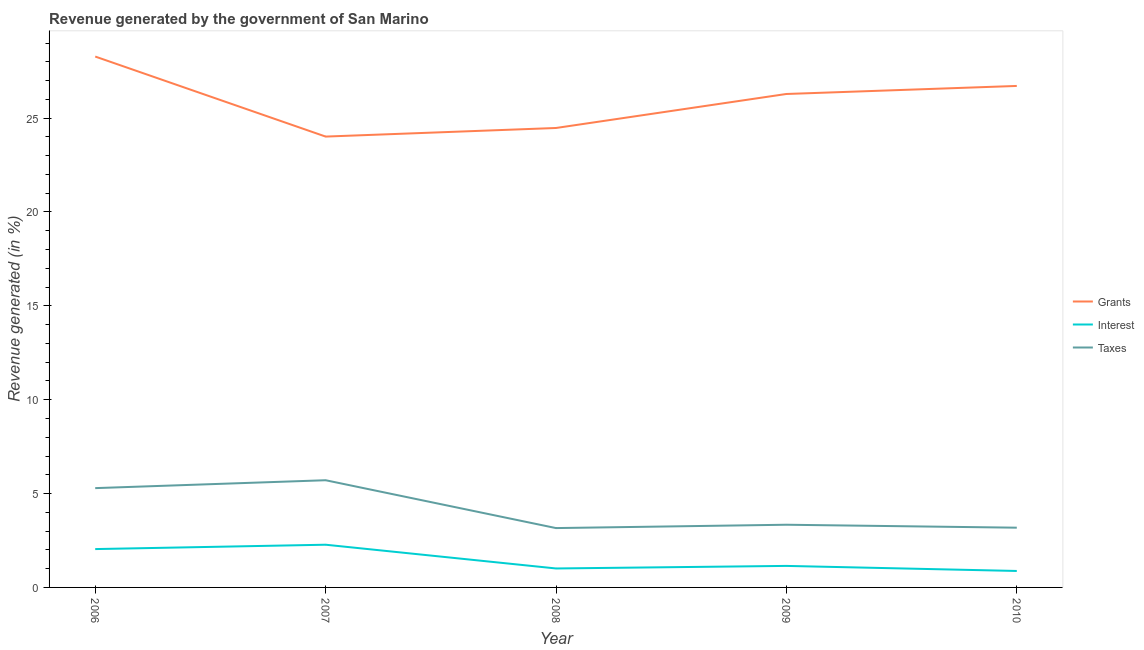How many different coloured lines are there?
Your answer should be compact. 3. Does the line corresponding to percentage of revenue generated by interest intersect with the line corresponding to percentage of revenue generated by taxes?
Make the answer very short. No. What is the percentage of revenue generated by taxes in 2010?
Offer a very short reply. 3.18. Across all years, what is the maximum percentage of revenue generated by interest?
Your answer should be compact. 2.28. Across all years, what is the minimum percentage of revenue generated by grants?
Keep it short and to the point. 24.02. In which year was the percentage of revenue generated by interest maximum?
Give a very brief answer. 2007. In which year was the percentage of revenue generated by interest minimum?
Ensure brevity in your answer.  2010. What is the total percentage of revenue generated by grants in the graph?
Make the answer very short. 129.77. What is the difference between the percentage of revenue generated by taxes in 2006 and that in 2007?
Give a very brief answer. -0.42. What is the difference between the percentage of revenue generated by taxes in 2007 and the percentage of revenue generated by interest in 2010?
Give a very brief answer. 4.83. What is the average percentage of revenue generated by taxes per year?
Ensure brevity in your answer.  4.14. In the year 2006, what is the difference between the percentage of revenue generated by grants and percentage of revenue generated by interest?
Your response must be concise. 26.24. In how many years, is the percentage of revenue generated by interest greater than 10 %?
Provide a short and direct response. 0. What is the ratio of the percentage of revenue generated by interest in 2007 to that in 2009?
Offer a terse response. 1.98. Is the difference between the percentage of revenue generated by taxes in 2006 and 2008 greater than the difference between the percentage of revenue generated by grants in 2006 and 2008?
Provide a short and direct response. No. What is the difference between the highest and the second highest percentage of revenue generated by grants?
Provide a succinct answer. 1.57. What is the difference between the highest and the lowest percentage of revenue generated by grants?
Make the answer very short. 4.26. In how many years, is the percentage of revenue generated by taxes greater than the average percentage of revenue generated by taxes taken over all years?
Your response must be concise. 2. Is the sum of the percentage of revenue generated by grants in 2007 and 2008 greater than the maximum percentage of revenue generated by interest across all years?
Your response must be concise. Yes. Does the percentage of revenue generated by interest monotonically increase over the years?
Make the answer very short. No. Is the percentage of revenue generated by taxes strictly greater than the percentage of revenue generated by grants over the years?
Provide a succinct answer. No. Is the percentage of revenue generated by grants strictly less than the percentage of revenue generated by taxes over the years?
Provide a short and direct response. No. How many lines are there?
Provide a short and direct response. 3. How many years are there in the graph?
Provide a short and direct response. 5. What is the difference between two consecutive major ticks on the Y-axis?
Ensure brevity in your answer.  5. Does the graph contain any zero values?
Offer a very short reply. No. Does the graph contain grids?
Provide a succinct answer. No. Where does the legend appear in the graph?
Your response must be concise. Center right. How many legend labels are there?
Make the answer very short. 3. What is the title of the graph?
Provide a short and direct response. Revenue generated by the government of San Marino. Does "Central government" appear as one of the legend labels in the graph?
Offer a terse response. No. What is the label or title of the X-axis?
Offer a terse response. Year. What is the label or title of the Y-axis?
Ensure brevity in your answer.  Revenue generated (in %). What is the Revenue generated (in %) in Grants in 2006?
Keep it short and to the point. 28.28. What is the Revenue generated (in %) in Interest in 2006?
Offer a terse response. 2.04. What is the Revenue generated (in %) of Taxes in 2006?
Provide a succinct answer. 5.29. What is the Revenue generated (in %) of Grants in 2007?
Your answer should be compact. 24.02. What is the Revenue generated (in %) in Interest in 2007?
Your answer should be compact. 2.28. What is the Revenue generated (in %) of Taxes in 2007?
Offer a very short reply. 5.71. What is the Revenue generated (in %) in Grants in 2008?
Keep it short and to the point. 24.47. What is the Revenue generated (in %) of Interest in 2008?
Your answer should be very brief. 1.01. What is the Revenue generated (in %) of Taxes in 2008?
Keep it short and to the point. 3.16. What is the Revenue generated (in %) in Grants in 2009?
Keep it short and to the point. 26.28. What is the Revenue generated (in %) in Interest in 2009?
Offer a very short reply. 1.15. What is the Revenue generated (in %) of Taxes in 2009?
Provide a short and direct response. 3.34. What is the Revenue generated (in %) in Grants in 2010?
Provide a short and direct response. 26.71. What is the Revenue generated (in %) in Interest in 2010?
Give a very brief answer. 0.88. What is the Revenue generated (in %) of Taxes in 2010?
Your response must be concise. 3.18. Across all years, what is the maximum Revenue generated (in %) in Grants?
Offer a very short reply. 28.28. Across all years, what is the maximum Revenue generated (in %) in Interest?
Provide a succinct answer. 2.28. Across all years, what is the maximum Revenue generated (in %) of Taxes?
Your response must be concise. 5.71. Across all years, what is the minimum Revenue generated (in %) of Grants?
Ensure brevity in your answer.  24.02. Across all years, what is the minimum Revenue generated (in %) in Interest?
Offer a very short reply. 0.88. Across all years, what is the minimum Revenue generated (in %) in Taxes?
Provide a short and direct response. 3.16. What is the total Revenue generated (in %) of Grants in the graph?
Your answer should be very brief. 129.77. What is the total Revenue generated (in %) in Interest in the graph?
Your answer should be compact. 7.35. What is the total Revenue generated (in %) of Taxes in the graph?
Offer a terse response. 20.68. What is the difference between the Revenue generated (in %) in Grants in 2006 and that in 2007?
Provide a succinct answer. 4.26. What is the difference between the Revenue generated (in %) in Interest in 2006 and that in 2007?
Provide a short and direct response. -0.23. What is the difference between the Revenue generated (in %) of Taxes in 2006 and that in 2007?
Your answer should be very brief. -0.42. What is the difference between the Revenue generated (in %) of Grants in 2006 and that in 2008?
Provide a succinct answer. 3.81. What is the difference between the Revenue generated (in %) in Interest in 2006 and that in 2008?
Give a very brief answer. 1.03. What is the difference between the Revenue generated (in %) of Taxes in 2006 and that in 2008?
Offer a very short reply. 2.13. What is the difference between the Revenue generated (in %) of Grants in 2006 and that in 2009?
Provide a succinct answer. 1.99. What is the difference between the Revenue generated (in %) of Interest in 2006 and that in 2009?
Your answer should be compact. 0.9. What is the difference between the Revenue generated (in %) in Taxes in 2006 and that in 2009?
Your response must be concise. 1.95. What is the difference between the Revenue generated (in %) in Grants in 2006 and that in 2010?
Your response must be concise. 1.57. What is the difference between the Revenue generated (in %) of Interest in 2006 and that in 2010?
Keep it short and to the point. 1.17. What is the difference between the Revenue generated (in %) in Taxes in 2006 and that in 2010?
Give a very brief answer. 2.11. What is the difference between the Revenue generated (in %) of Grants in 2007 and that in 2008?
Provide a short and direct response. -0.46. What is the difference between the Revenue generated (in %) in Interest in 2007 and that in 2008?
Provide a succinct answer. 1.27. What is the difference between the Revenue generated (in %) in Taxes in 2007 and that in 2008?
Offer a very short reply. 2.55. What is the difference between the Revenue generated (in %) of Grants in 2007 and that in 2009?
Your answer should be compact. -2.27. What is the difference between the Revenue generated (in %) of Interest in 2007 and that in 2009?
Ensure brevity in your answer.  1.13. What is the difference between the Revenue generated (in %) in Taxes in 2007 and that in 2009?
Offer a very short reply. 2.37. What is the difference between the Revenue generated (in %) of Grants in 2007 and that in 2010?
Keep it short and to the point. -2.7. What is the difference between the Revenue generated (in %) in Interest in 2007 and that in 2010?
Provide a succinct answer. 1.4. What is the difference between the Revenue generated (in %) in Taxes in 2007 and that in 2010?
Provide a short and direct response. 2.53. What is the difference between the Revenue generated (in %) of Grants in 2008 and that in 2009?
Give a very brief answer. -1.81. What is the difference between the Revenue generated (in %) in Interest in 2008 and that in 2009?
Offer a very short reply. -0.14. What is the difference between the Revenue generated (in %) of Taxes in 2008 and that in 2009?
Make the answer very short. -0.18. What is the difference between the Revenue generated (in %) of Grants in 2008 and that in 2010?
Make the answer very short. -2.24. What is the difference between the Revenue generated (in %) in Interest in 2008 and that in 2010?
Offer a terse response. 0.13. What is the difference between the Revenue generated (in %) of Taxes in 2008 and that in 2010?
Keep it short and to the point. -0.02. What is the difference between the Revenue generated (in %) of Grants in 2009 and that in 2010?
Your answer should be compact. -0.43. What is the difference between the Revenue generated (in %) of Interest in 2009 and that in 2010?
Your response must be concise. 0.27. What is the difference between the Revenue generated (in %) of Taxes in 2009 and that in 2010?
Ensure brevity in your answer.  0.16. What is the difference between the Revenue generated (in %) in Grants in 2006 and the Revenue generated (in %) in Interest in 2007?
Offer a very short reply. 26. What is the difference between the Revenue generated (in %) of Grants in 2006 and the Revenue generated (in %) of Taxes in 2007?
Your answer should be very brief. 22.57. What is the difference between the Revenue generated (in %) in Interest in 2006 and the Revenue generated (in %) in Taxes in 2007?
Provide a short and direct response. -3.67. What is the difference between the Revenue generated (in %) in Grants in 2006 and the Revenue generated (in %) in Interest in 2008?
Ensure brevity in your answer.  27.27. What is the difference between the Revenue generated (in %) of Grants in 2006 and the Revenue generated (in %) of Taxes in 2008?
Give a very brief answer. 25.12. What is the difference between the Revenue generated (in %) in Interest in 2006 and the Revenue generated (in %) in Taxes in 2008?
Provide a succinct answer. -1.12. What is the difference between the Revenue generated (in %) of Grants in 2006 and the Revenue generated (in %) of Interest in 2009?
Ensure brevity in your answer.  27.13. What is the difference between the Revenue generated (in %) of Grants in 2006 and the Revenue generated (in %) of Taxes in 2009?
Offer a terse response. 24.94. What is the difference between the Revenue generated (in %) in Interest in 2006 and the Revenue generated (in %) in Taxes in 2009?
Give a very brief answer. -1.3. What is the difference between the Revenue generated (in %) in Grants in 2006 and the Revenue generated (in %) in Interest in 2010?
Provide a short and direct response. 27.4. What is the difference between the Revenue generated (in %) in Grants in 2006 and the Revenue generated (in %) in Taxes in 2010?
Offer a terse response. 25.1. What is the difference between the Revenue generated (in %) in Interest in 2006 and the Revenue generated (in %) in Taxes in 2010?
Your response must be concise. -1.14. What is the difference between the Revenue generated (in %) in Grants in 2007 and the Revenue generated (in %) in Interest in 2008?
Make the answer very short. 23.01. What is the difference between the Revenue generated (in %) in Grants in 2007 and the Revenue generated (in %) in Taxes in 2008?
Provide a succinct answer. 20.85. What is the difference between the Revenue generated (in %) in Interest in 2007 and the Revenue generated (in %) in Taxes in 2008?
Give a very brief answer. -0.89. What is the difference between the Revenue generated (in %) in Grants in 2007 and the Revenue generated (in %) in Interest in 2009?
Make the answer very short. 22.87. What is the difference between the Revenue generated (in %) of Grants in 2007 and the Revenue generated (in %) of Taxes in 2009?
Provide a short and direct response. 20.68. What is the difference between the Revenue generated (in %) in Interest in 2007 and the Revenue generated (in %) in Taxes in 2009?
Offer a terse response. -1.06. What is the difference between the Revenue generated (in %) of Grants in 2007 and the Revenue generated (in %) of Interest in 2010?
Ensure brevity in your answer.  23.14. What is the difference between the Revenue generated (in %) in Grants in 2007 and the Revenue generated (in %) in Taxes in 2010?
Give a very brief answer. 20.83. What is the difference between the Revenue generated (in %) of Interest in 2007 and the Revenue generated (in %) of Taxes in 2010?
Give a very brief answer. -0.91. What is the difference between the Revenue generated (in %) of Grants in 2008 and the Revenue generated (in %) of Interest in 2009?
Your answer should be compact. 23.33. What is the difference between the Revenue generated (in %) in Grants in 2008 and the Revenue generated (in %) in Taxes in 2009?
Your response must be concise. 21.13. What is the difference between the Revenue generated (in %) in Interest in 2008 and the Revenue generated (in %) in Taxes in 2009?
Provide a succinct answer. -2.33. What is the difference between the Revenue generated (in %) in Grants in 2008 and the Revenue generated (in %) in Interest in 2010?
Offer a very short reply. 23.6. What is the difference between the Revenue generated (in %) in Grants in 2008 and the Revenue generated (in %) in Taxes in 2010?
Your answer should be very brief. 21.29. What is the difference between the Revenue generated (in %) in Interest in 2008 and the Revenue generated (in %) in Taxes in 2010?
Your answer should be compact. -2.17. What is the difference between the Revenue generated (in %) of Grants in 2009 and the Revenue generated (in %) of Interest in 2010?
Keep it short and to the point. 25.41. What is the difference between the Revenue generated (in %) in Grants in 2009 and the Revenue generated (in %) in Taxes in 2010?
Your answer should be very brief. 23.1. What is the difference between the Revenue generated (in %) in Interest in 2009 and the Revenue generated (in %) in Taxes in 2010?
Your answer should be very brief. -2.04. What is the average Revenue generated (in %) in Grants per year?
Give a very brief answer. 25.95. What is the average Revenue generated (in %) of Interest per year?
Offer a very short reply. 1.47. What is the average Revenue generated (in %) of Taxes per year?
Ensure brevity in your answer.  4.14. In the year 2006, what is the difference between the Revenue generated (in %) of Grants and Revenue generated (in %) of Interest?
Provide a succinct answer. 26.24. In the year 2006, what is the difference between the Revenue generated (in %) in Grants and Revenue generated (in %) in Taxes?
Provide a short and direct response. 22.99. In the year 2006, what is the difference between the Revenue generated (in %) of Interest and Revenue generated (in %) of Taxes?
Offer a very short reply. -3.25. In the year 2007, what is the difference between the Revenue generated (in %) in Grants and Revenue generated (in %) in Interest?
Your response must be concise. 21.74. In the year 2007, what is the difference between the Revenue generated (in %) in Grants and Revenue generated (in %) in Taxes?
Your response must be concise. 18.31. In the year 2007, what is the difference between the Revenue generated (in %) in Interest and Revenue generated (in %) in Taxes?
Keep it short and to the point. -3.43. In the year 2008, what is the difference between the Revenue generated (in %) in Grants and Revenue generated (in %) in Interest?
Offer a terse response. 23.46. In the year 2008, what is the difference between the Revenue generated (in %) in Grants and Revenue generated (in %) in Taxes?
Your response must be concise. 21.31. In the year 2008, what is the difference between the Revenue generated (in %) in Interest and Revenue generated (in %) in Taxes?
Make the answer very short. -2.15. In the year 2009, what is the difference between the Revenue generated (in %) in Grants and Revenue generated (in %) in Interest?
Your response must be concise. 25.14. In the year 2009, what is the difference between the Revenue generated (in %) in Grants and Revenue generated (in %) in Taxes?
Provide a short and direct response. 22.94. In the year 2009, what is the difference between the Revenue generated (in %) of Interest and Revenue generated (in %) of Taxes?
Give a very brief answer. -2.19. In the year 2010, what is the difference between the Revenue generated (in %) in Grants and Revenue generated (in %) in Interest?
Provide a succinct answer. 25.84. In the year 2010, what is the difference between the Revenue generated (in %) in Grants and Revenue generated (in %) in Taxes?
Your answer should be compact. 23.53. In the year 2010, what is the difference between the Revenue generated (in %) of Interest and Revenue generated (in %) of Taxes?
Provide a short and direct response. -2.31. What is the ratio of the Revenue generated (in %) in Grants in 2006 to that in 2007?
Your answer should be very brief. 1.18. What is the ratio of the Revenue generated (in %) in Interest in 2006 to that in 2007?
Keep it short and to the point. 0.9. What is the ratio of the Revenue generated (in %) in Taxes in 2006 to that in 2007?
Provide a short and direct response. 0.93. What is the ratio of the Revenue generated (in %) of Grants in 2006 to that in 2008?
Your answer should be compact. 1.16. What is the ratio of the Revenue generated (in %) in Interest in 2006 to that in 2008?
Make the answer very short. 2.02. What is the ratio of the Revenue generated (in %) in Taxes in 2006 to that in 2008?
Make the answer very short. 1.67. What is the ratio of the Revenue generated (in %) in Grants in 2006 to that in 2009?
Offer a terse response. 1.08. What is the ratio of the Revenue generated (in %) in Interest in 2006 to that in 2009?
Your answer should be compact. 1.78. What is the ratio of the Revenue generated (in %) of Taxes in 2006 to that in 2009?
Give a very brief answer. 1.58. What is the ratio of the Revenue generated (in %) of Grants in 2006 to that in 2010?
Ensure brevity in your answer.  1.06. What is the ratio of the Revenue generated (in %) in Interest in 2006 to that in 2010?
Your response must be concise. 2.33. What is the ratio of the Revenue generated (in %) of Taxes in 2006 to that in 2010?
Provide a succinct answer. 1.66. What is the ratio of the Revenue generated (in %) in Grants in 2007 to that in 2008?
Keep it short and to the point. 0.98. What is the ratio of the Revenue generated (in %) in Interest in 2007 to that in 2008?
Your answer should be compact. 2.25. What is the ratio of the Revenue generated (in %) in Taxes in 2007 to that in 2008?
Your answer should be compact. 1.81. What is the ratio of the Revenue generated (in %) in Grants in 2007 to that in 2009?
Your answer should be compact. 0.91. What is the ratio of the Revenue generated (in %) of Interest in 2007 to that in 2009?
Ensure brevity in your answer.  1.98. What is the ratio of the Revenue generated (in %) of Taxes in 2007 to that in 2009?
Your answer should be very brief. 1.71. What is the ratio of the Revenue generated (in %) of Grants in 2007 to that in 2010?
Keep it short and to the point. 0.9. What is the ratio of the Revenue generated (in %) in Interest in 2007 to that in 2010?
Give a very brief answer. 2.6. What is the ratio of the Revenue generated (in %) of Taxes in 2007 to that in 2010?
Offer a very short reply. 1.79. What is the ratio of the Revenue generated (in %) in Grants in 2008 to that in 2009?
Make the answer very short. 0.93. What is the ratio of the Revenue generated (in %) in Interest in 2008 to that in 2009?
Give a very brief answer. 0.88. What is the ratio of the Revenue generated (in %) in Taxes in 2008 to that in 2009?
Your answer should be compact. 0.95. What is the ratio of the Revenue generated (in %) in Grants in 2008 to that in 2010?
Give a very brief answer. 0.92. What is the ratio of the Revenue generated (in %) of Interest in 2008 to that in 2010?
Make the answer very short. 1.15. What is the ratio of the Revenue generated (in %) in Interest in 2009 to that in 2010?
Provide a short and direct response. 1.31. What is the ratio of the Revenue generated (in %) in Taxes in 2009 to that in 2010?
Give a very brief answer. 1.05. What is the difference between the highest and the second highest Revenue generated (in %) of Grants?
Provide a short and direct response. 1.57. What is the difference between the highest and the second highest Revenue generated (in %) in Interest?
Offer a terse response. 0.23. What is the difference between the highest and the second highest Revenue generated (in %) of Taxes?
Your answer should be compact. 0.42. What is the difference between the highest and the lowest Revenue generated (in %) of Grants?
Offer a very short reply. 4.26. What is the difference between the highest and the lowest Revenue generated (in %) in Interest?
Offer a terse response. 1.4. What is the difference between the highest and the lowest Revenue generated (in %) of Taxes?
Offer a very short reply. 2.55. 